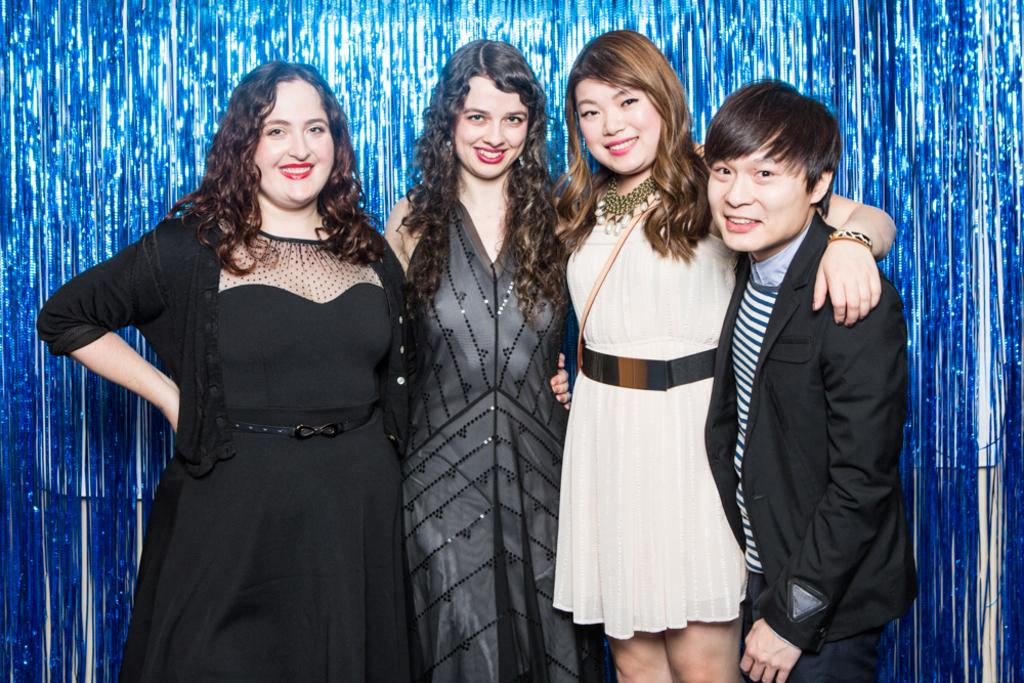Who is standing on the right side of the image? There is a man standing on the right side of the image. What is the man wearing? The man is wearing a black coat. Who is standing beside the man? There is a beautiful girl standing beside the man. What is the beautiful girl wearing? The beautiful girl is wearing a white dress. How many other girls are standing beside the beautiful girl? There are two other girls standing beside the beautiful girl. What is the facial expression of the two other girls? The two other girls are smiling. What grade does the hope of light receive in the image? There is no mention of hope or light in the image, and therefore no grade can be assigned. 